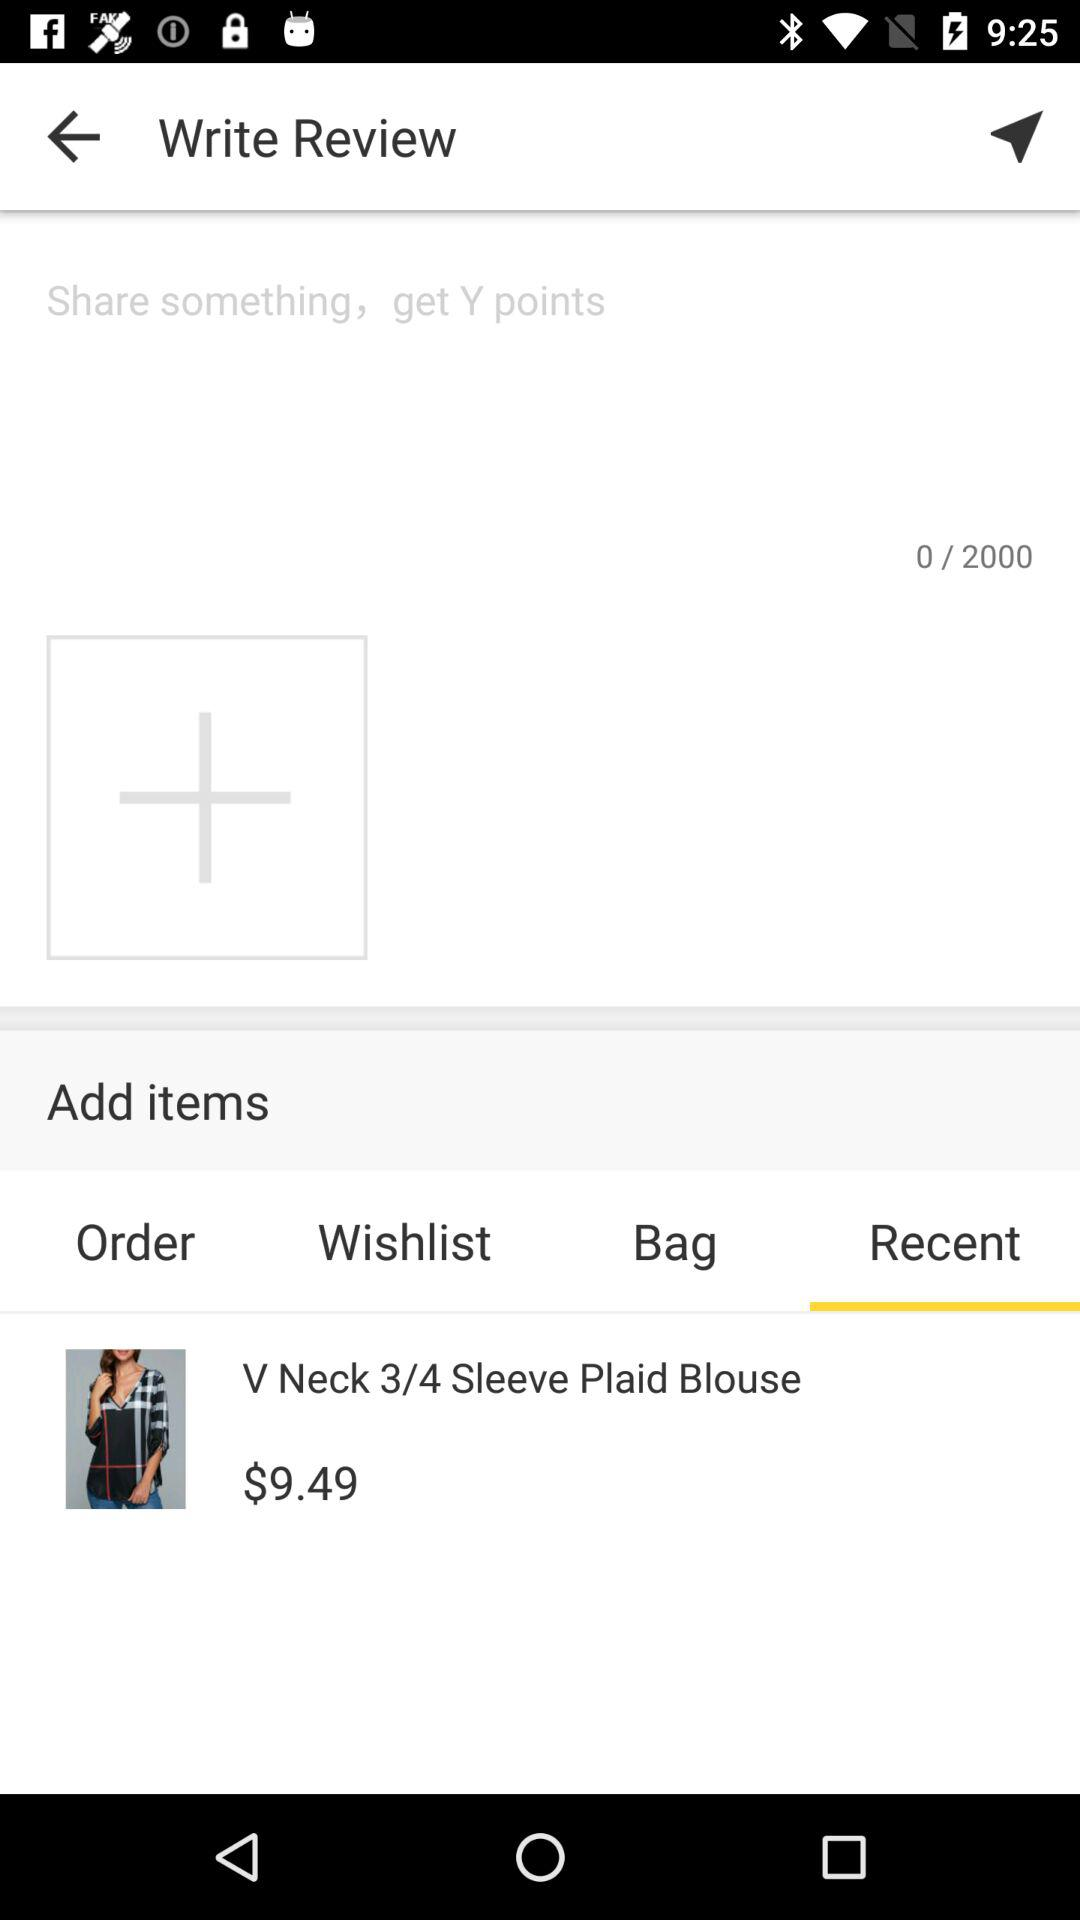Which tab is selected? The selected tab is "Recent". 